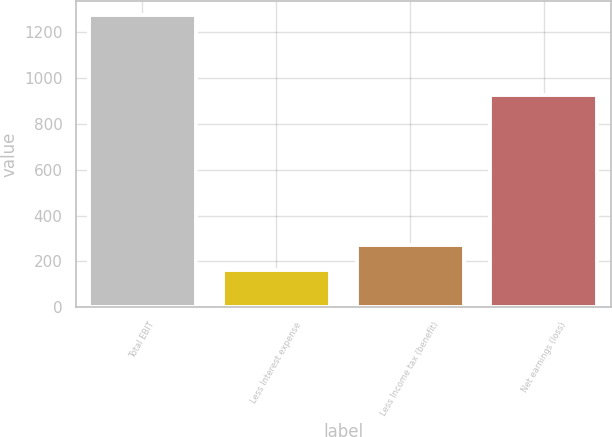Convert chart to OTSL. <chart><loc_0><loc_0><loc_500><loc_500><bar_chart><fcel>Total EBIT<fcel>Less Interest expense<fcel>Less Income tax (benefit)<fcel>Net earnings (loss)<nl><fcel>1275<fcel>161<fcel>272.4<fcel>928<nl></chart> 